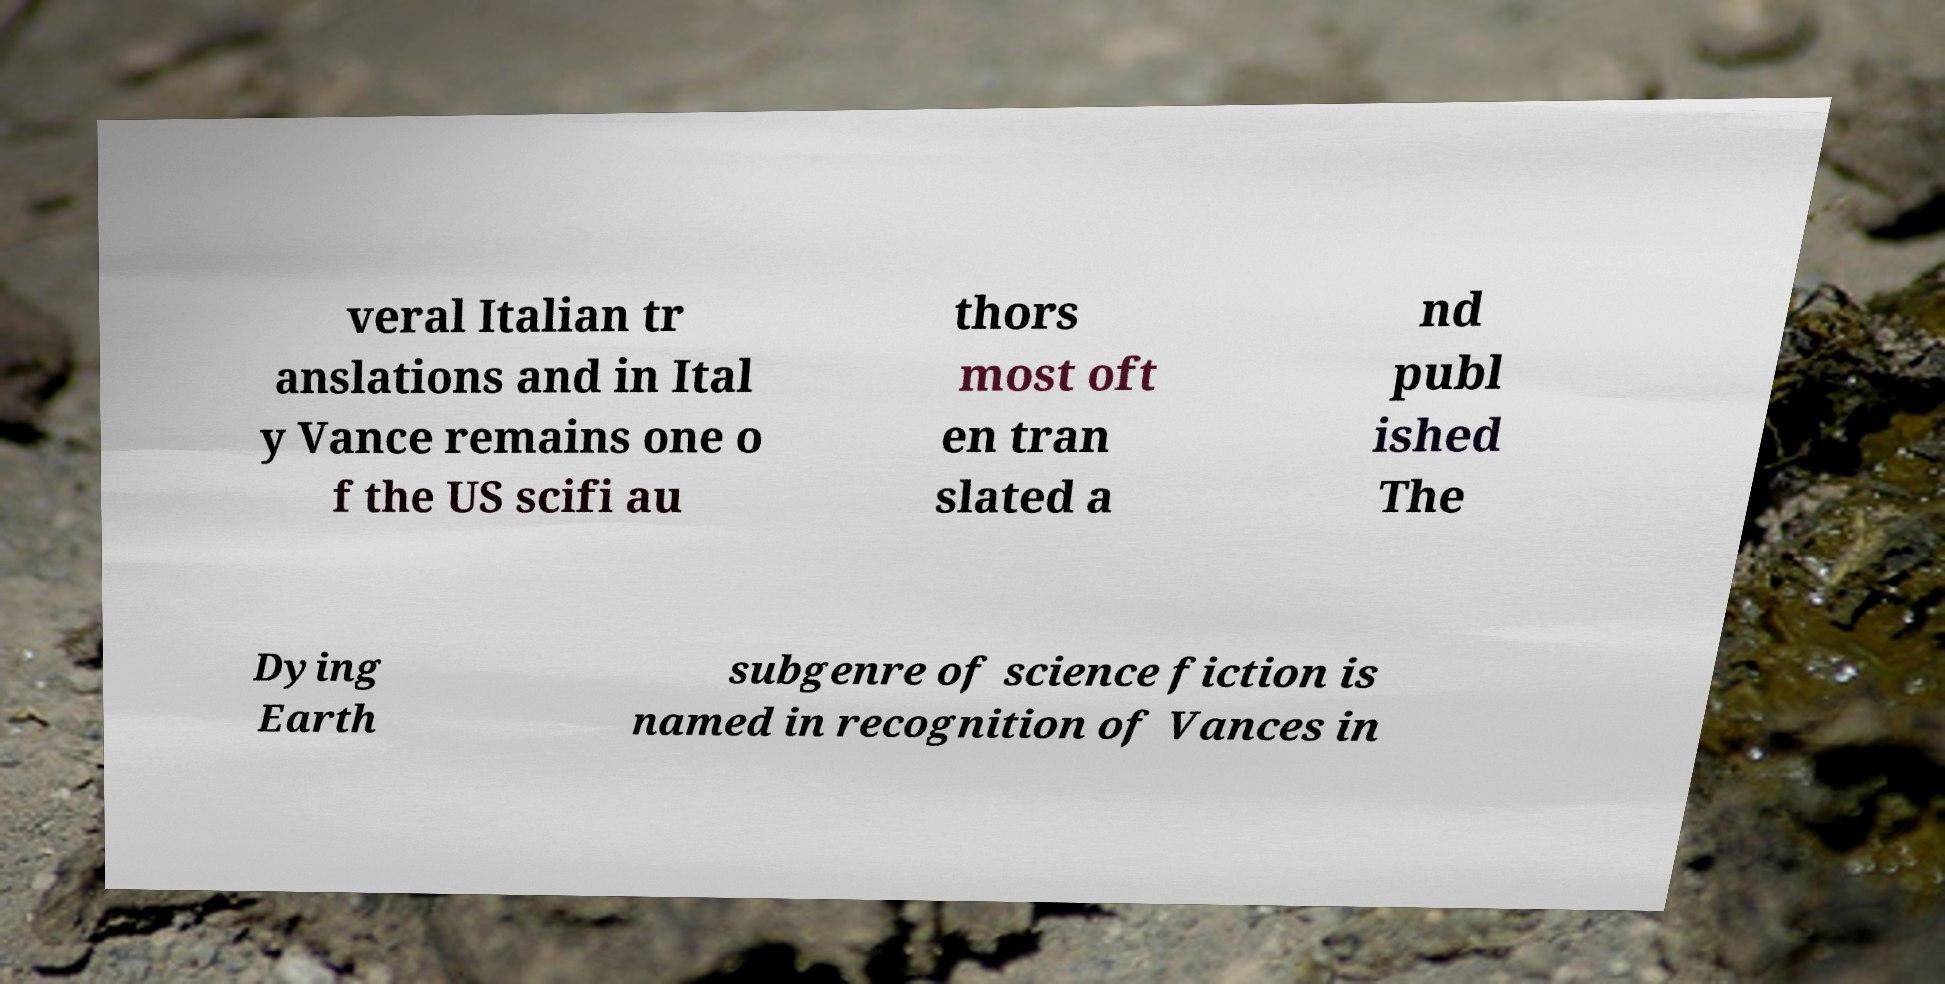Can you accurately transcribe the text from the provided image for me? veral Italian tr anslations and in Ital y Vance remains one o f the US scifi au thors most oft en tran slated a nd publ ished The Dying Earth subgenre of science fiction is named in recognition of Vances in 